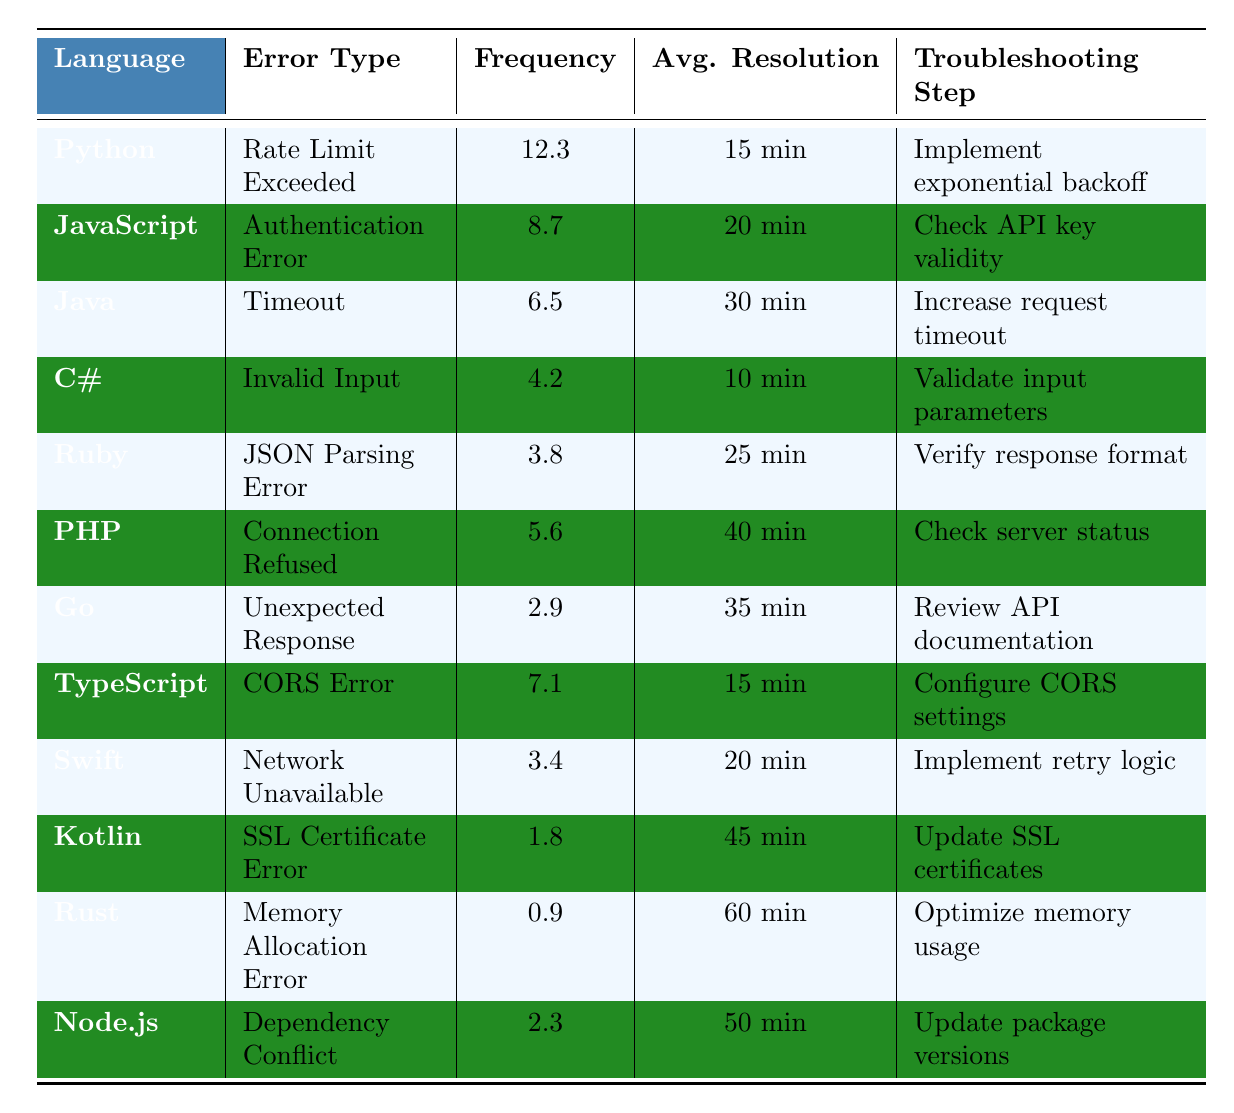What is the error type with the highest frequency in Python? The table shows that the error type for Python is "Rate Limit Exceeded," with a frequency of 12.3 per 1000 API calls, which is the highest compared to other programming languages listed.
Answer: Rate Limit Exceeded Which programming language has the longest average resolution time? By examining the "Average Resolution Time" column, we see that Kotlin has the longest time listed at 45 minutes, which is greater than any other language's average resolution time.
Answer: Kotlin What is the frequency of "Authentication Error" in JavaScript? The table lists JavaScript's frequency of "Authentication Error" as 8.7 per 1000 API calls, directly stated in the frequency column next to JavaScript.
Answer: 8.7 Is the common troubleshooting step for the "Connection Refused" error also applicable to any other error types? The troubleshooting step for "Connection Refused" is to "Check server status." This step is not repeated for any other error type; thus, it is unique to its corresponding error.
Answer: No What is the difference in frequency between "Rate Limit Exceeded" for Python and "Memory Allocation Error" for Rust? The frequency of "Rate Limit Exceeded" is 12.3 (Python) and "Memory Allocation Error" is 0.9 (Rust). The difference between them is 12.3 - 0.9 = 11.4 per 1000 API calls.
Answer: 11.4 Which error type in Go has a shorter average resolution time than the error type "Invalid Input" in C#? In the table, "Invalid Input" in C# has an average resolution time of 10 minutes, while Go's "Unexpected Response" has a resolution time of 35 minutes. Since 35 is greater than 10, there is no error type for Go with a shorter resolution time than C#.
Answer: No Which two error types have the lowest frequency of occurrence? The frequencies for Kotlin (1.8) and Rust (0.9) are the lowest. Therefore, both errors correspond with their respective programming languages in terms of frequency.
Answer: SSL Certificate Error (Kotlin) and Memory Allocation Error (Rust) What is the average resolution time for all error types combined? Adding the average resolution times: (15 + 20 + 30 + 10 + 25 + 40 + 35 + 15 + 20 + 45 + 60 + 50) gives a total of 350 minutes. Dividing by the number of error types (12), we find the average resolution time to be approximately 29.17 minutes.
Answer: 29.17 minutes Which programming language has the highest average resolution time for its errors? The average resolution time for Kotlin's "SSL Certificate Error" is 45 minutes, and this is higher than all other programming languages listed.
Answer: Kotlin 